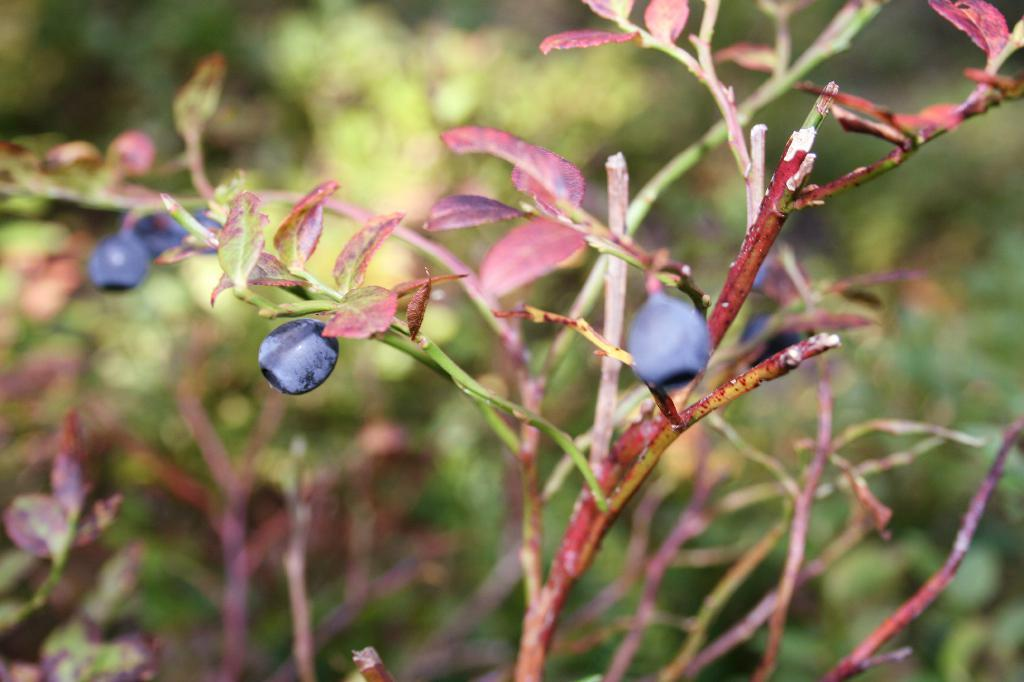What type of living organism is present in the image? There is a plant in the image. What are the main features of the plant? The plant has leaves and fruits. Can you describe the surrounding environment in the image? There are other plants in the background of the image. What type of brain can be seen in the image? There is no brain present in the image; it features a plant with leaves and fruits. Are there any fairies visible in the image? There are no fairies present in the image. 